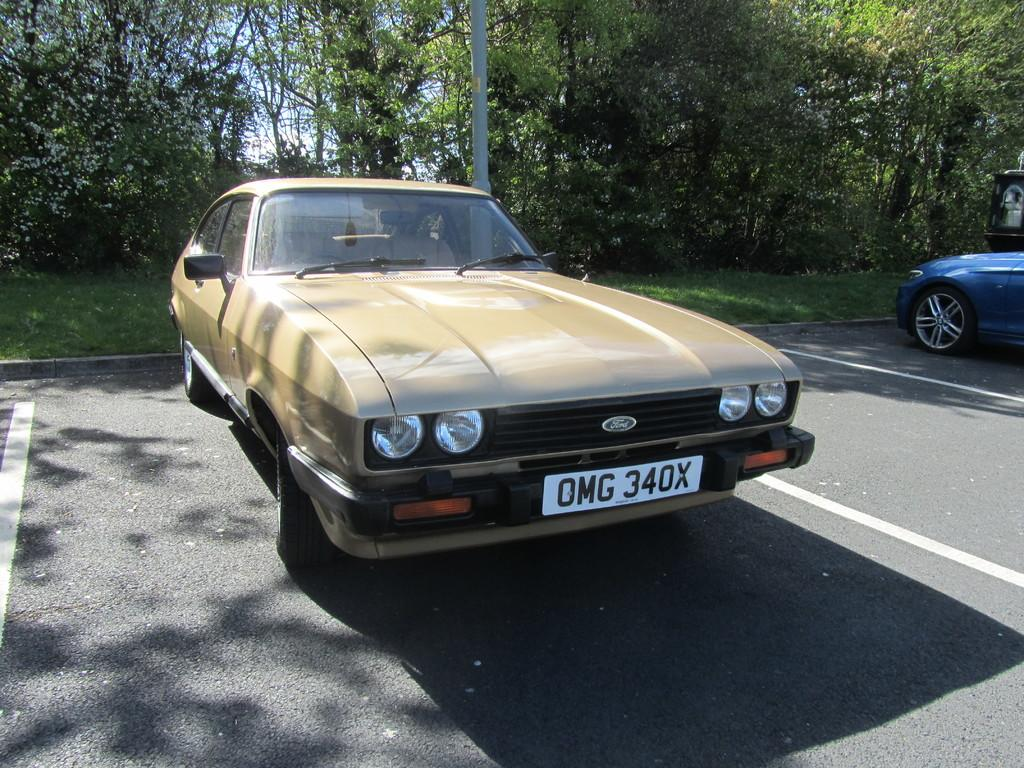How many cars are in the image? There are two cars in the image. What can be seen in the background of the image? There are trees, grass, and a pond in the background of the image. What is visible at the top of the image? The sky is visible at the top of the image. What type of thread is being used to sew the wall in the image? There is no wall or thread present in the image. What type of poison is visible in the image? There is no poison present in the image. 